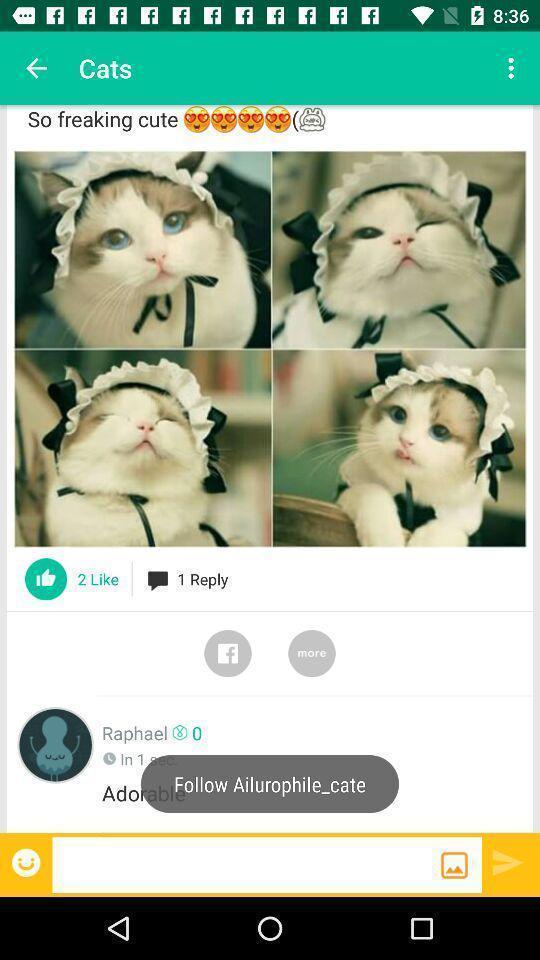Provide a detailed account of this screenshot. Page with cat images in a social app. 